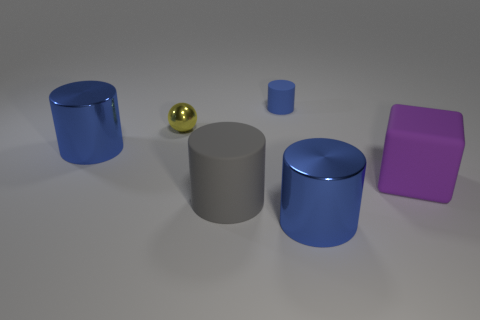The matte thing that is behind the big rubber cube has what shape?
Your answer should be very brief. Cylinder. How many objects are big shiny cylinders or large cyan metallic balls?
Your answer should be compact. 2. There is a ball; is its size the same as the blue metallic object to the left of the small blue rubber cylinder?
Make the answer very short. No. How many other objects are there of the same material as the tiny ball?
Keep it short and to the point. 2. How many things are blue things in front of the tiny sphere or matte things behind the tiny shiny thing?
Your answer should be compact. 3. There is a gray thing that is the same shape as the blue matte thing; what is its material?
Your answer should be compact. Rubber. Are there any large gray shiny balls?
Your answer should be very brief. No. What is the size of the metal object that is both to the left of the tiny blue matte thing and in front of the shiny ball?
Give a very brief answer. Large. There is a yellow object; what shape is it?
Make the answer very short. Sphere. There is a big blue metal object in front of the matte cube; is there a big blue cylinder that is to the right of it?
Give a very brief answer. No. 